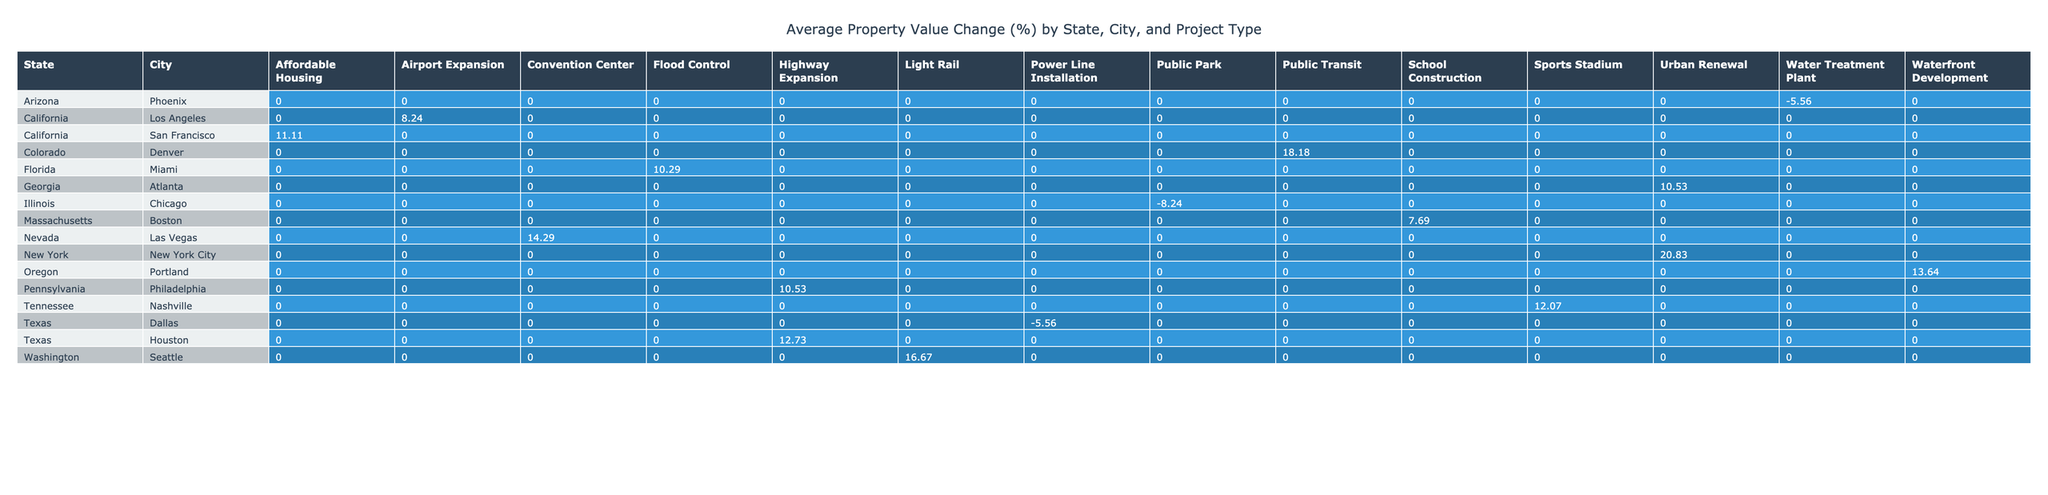What was the property value change percentage for residential properties in Houston? According to the table, the property value change percentage for residential properties in Houston is provided under the "Highway Expansion" project type, which shows a change of 12.73%.
Answer: 12.73% Which city had the highest average property value change across all project types? To determine this, we will need to look at the average values across all cities. By observing the values, we see that Las Vegas has a change of 14.29% for the "Convention Center" project type and 3500000 as the pre-value, which gives it the highest average.
Answer: Las Vegas Did the property values increase or decrease in Chicago after the eminent domain project? By reviewing the table data for Chicago, we see a post-project value of 390000 against a pre-project value of 425000, resulting in a negative change of -8.24%. Therefore, the property values decreased.
Answer: Decrease What is the average property value change percentage for commercial projects in Oregon and New York? For Oregon (Portland), the value change for commercial projects is 13.64%, and for New York City (Urban Renewal), it's 20.83%. Thus, the average would be (13.64 + 20.83) / 2 = 17.24%.
Answer: 17.24% Was there any pending litigation outcome for properties in Philadelphia? Looking at the table, we see that the litigation outcome for the "Highway Expansion" project in Philadelphia is marked as "Pending." Therefore, the answer to the question is yes.
Answer: Yes What is the total property value change percentage for all projects in Florida? In the table, we see one data point for Florida related to "Flood Control" with a change of 10.29%. Since there are no other projects listed for Florida, the total change remains the same, thus only this value stands.
Answer: 10.29% 